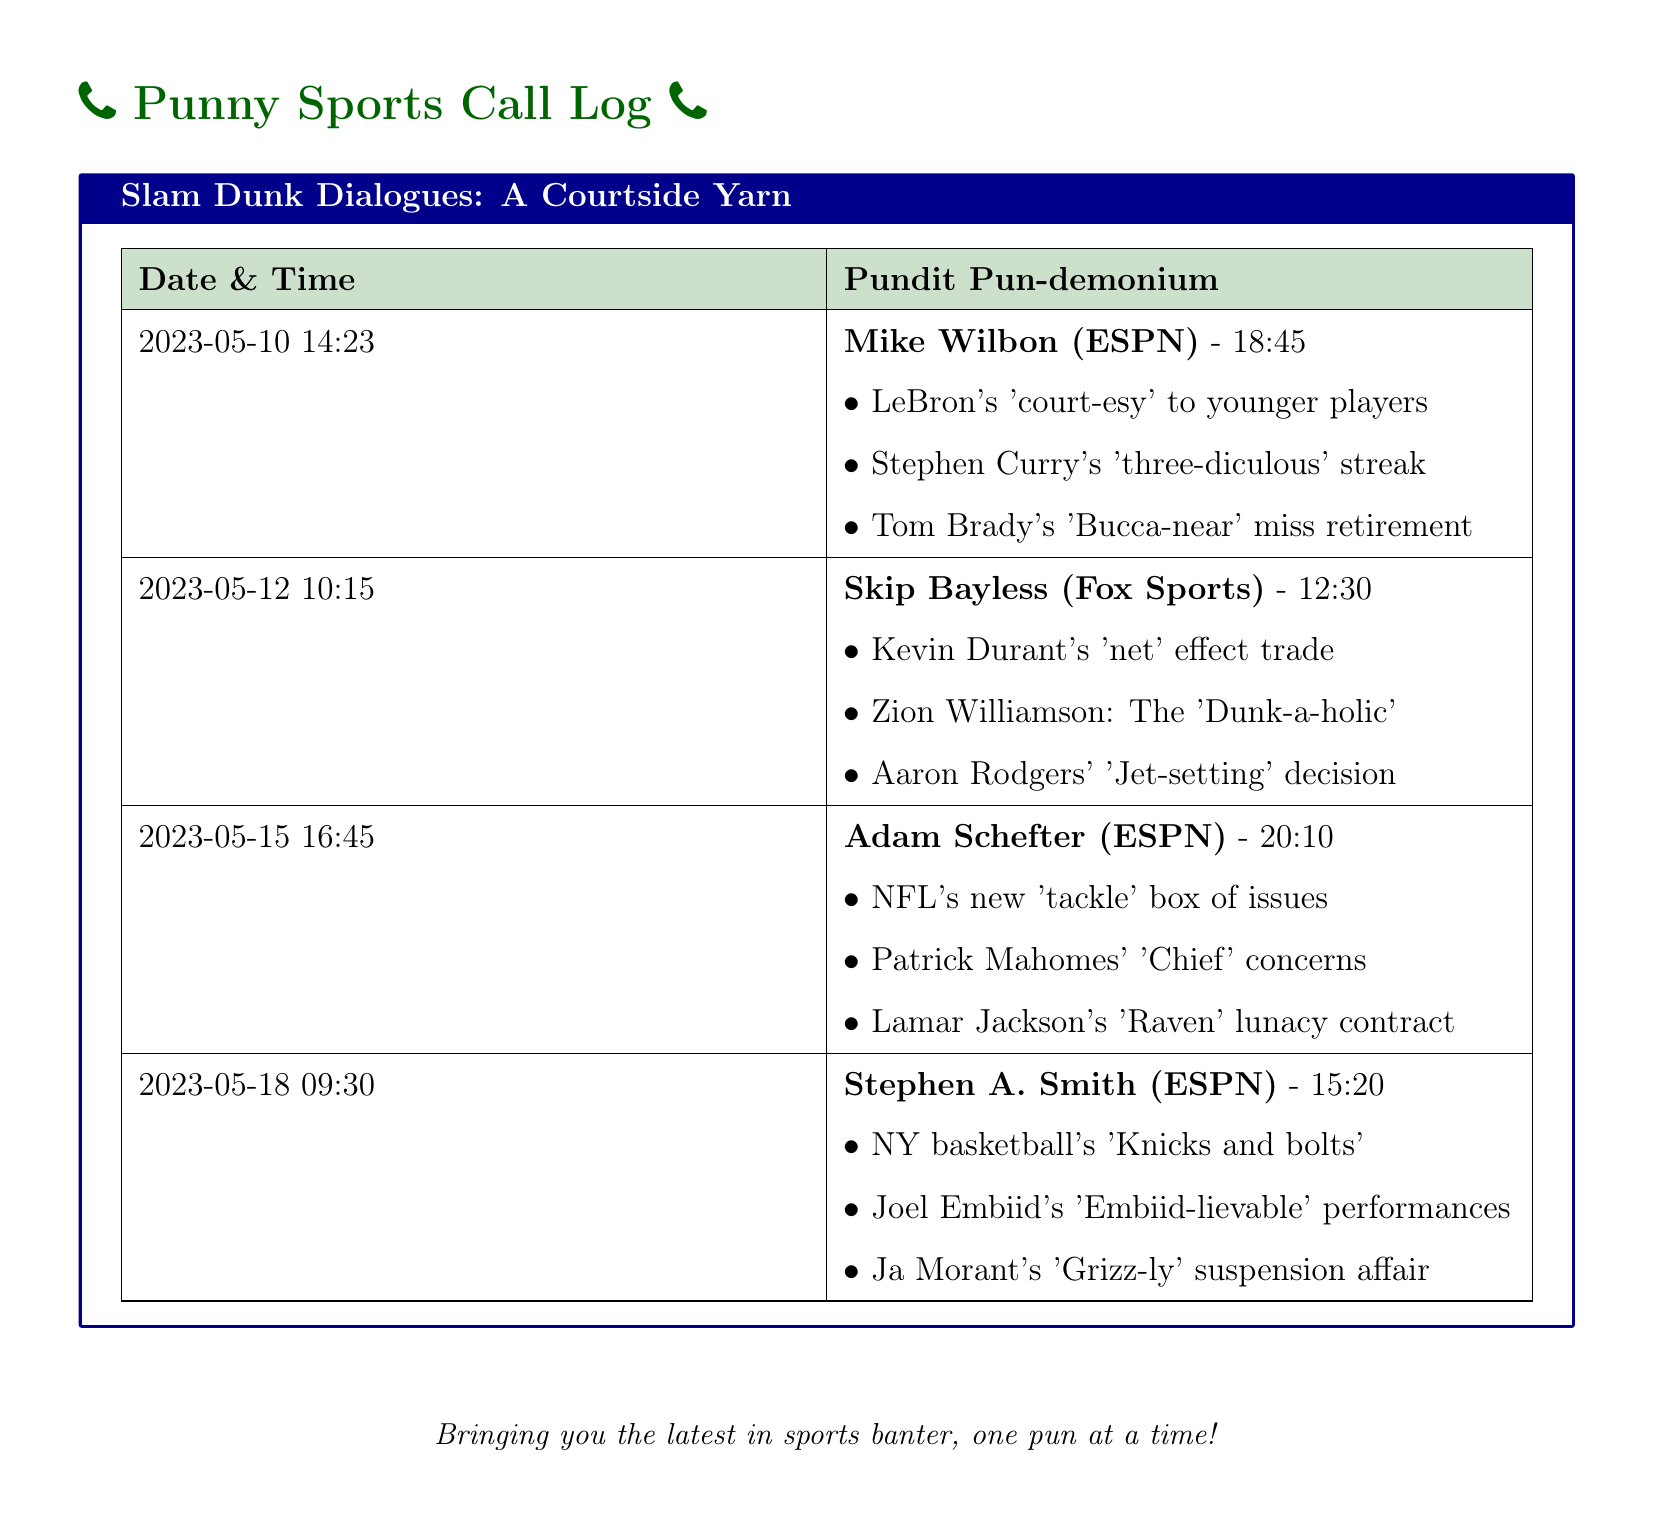What date was the call with Mike Wilbon? The date of the call with Mike Wilbon is listed in the document under the Date & Time column.
Answer: 2023-05-10 What was Stephen A. Smith's pun about Joel Embiid? This pun is specifically highlighted in the exchanges with Stephen A. Smith, calling out Joel Embiid's outstanding play.
Answer: Embiid-lievable Which pundit referred to Kevin Durant's trade? The document specifies which pundit discussed the effects of Kevin Durant's trade in the relevant section.
Answer: Skip Bayless How long did the call with Adam Schefter last? The duration of the call is indicated alongside the pundit's name, specifying the length of the conversation.
Answer: 20:10 What is the pun associated with Aaron Rodgers? The pun related to Aaron Rodgers can be found within the context of his recent decisions discussed by Skip Bayless.
Answer: Jet-setting What concern did Patrick Mahomes have according to Adam Schefter? This concern is noted in the dialog with Adam Schefter, offering insight into his perspective on Mahomes’ situation.
Answer: Chief concerns Which team's issues are referred to as a 'tackle box'? The term 'tackle box' is used to illustrate NFL issues, which is mentioned by a specific pundit in the document.
Answer: NFL What does the term "Grizz-ly" refer to? This term is used by Stephen A. Smith to describe a recent incident involving a specific player in the NBA, as detailed in the logs.
Answer: Ja Morant's suspension 